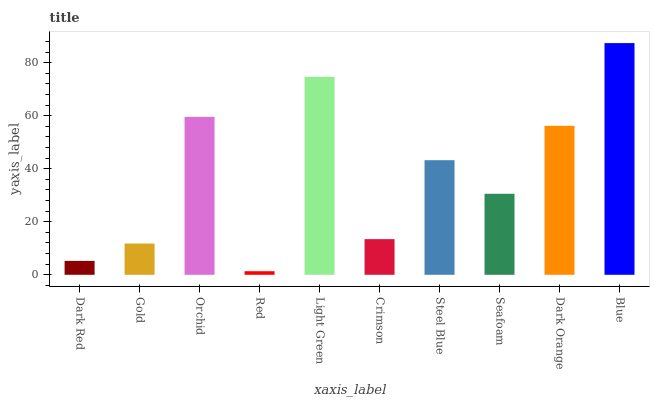Is Gold the minimum?
Answer yes or no. No. Is Gold the maximum?
Answer yes or no. No. Is Gold greater than Dark Red?
Answer yes or no. Yes. Is Dark Red less than Gold?
Answer yes or no. Yes. Is Dark Red greater than Gold?
Answer yes or no. No. Is Gold less than Dark Red?
Answer yes or no. No. Is Steel Blue the high median?
Answer yes or no. Yes. Is Seafoam the low median?
Answer yes or no. Yes. Is Orchid the high median?
Answer yes or no. No. Is Blue the low median?
Answer yes or no. No. 